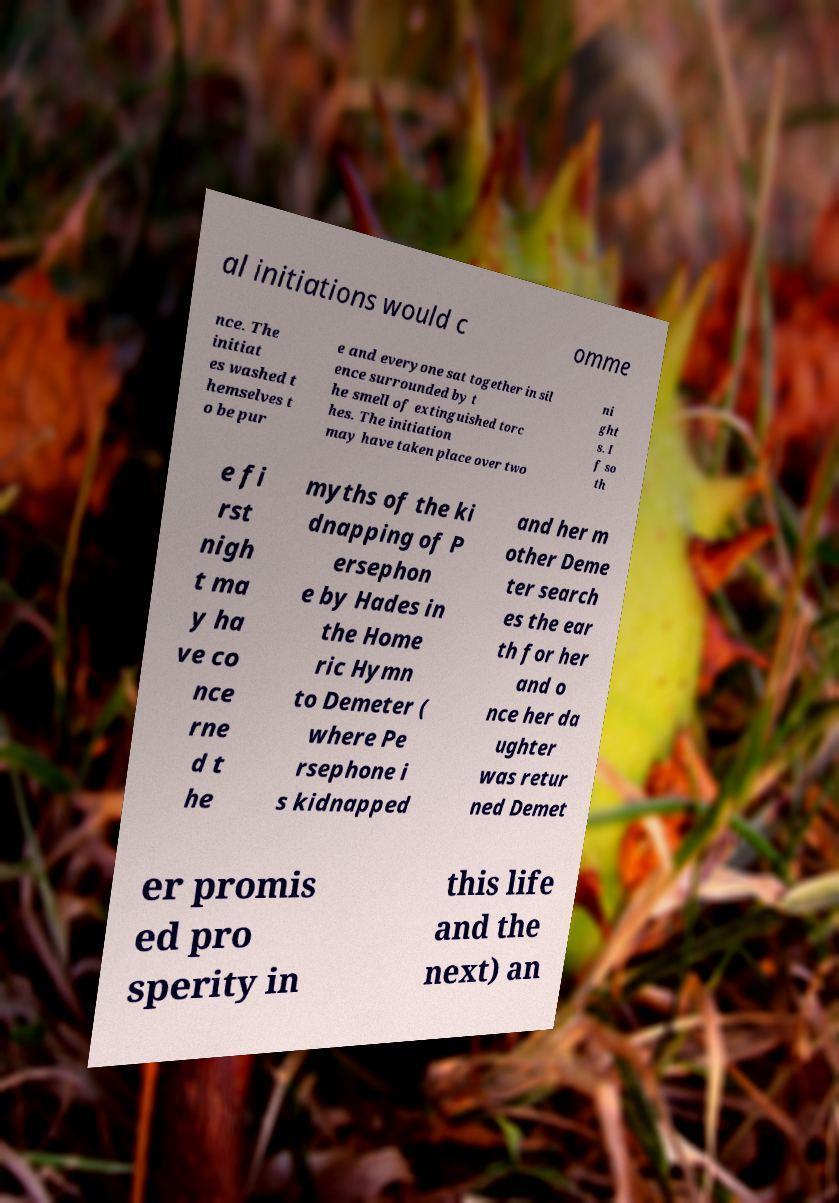What messages or text are displayed in this image? I need them in a readable, typed format. al initiations would c omme nce. The initiat es washed t hemselves t o be pur e and everyone sat together in sil ence surrounded by t he smell of extinguished torc hes. The initiation may have taken place over two ni ght s. I f so th e fi rst nigh t ma y ha ve co nce rne d t he myths of the ki dnapping of P ersephon e by Hades in the Home ric Hymn to Demeter ( where Pe rsephone i s kidnapped and her m other Deme ter search es the ear th for her and o nce her da ughter was retur ned Demet er promis ed pro sperity in this life and the next) an 